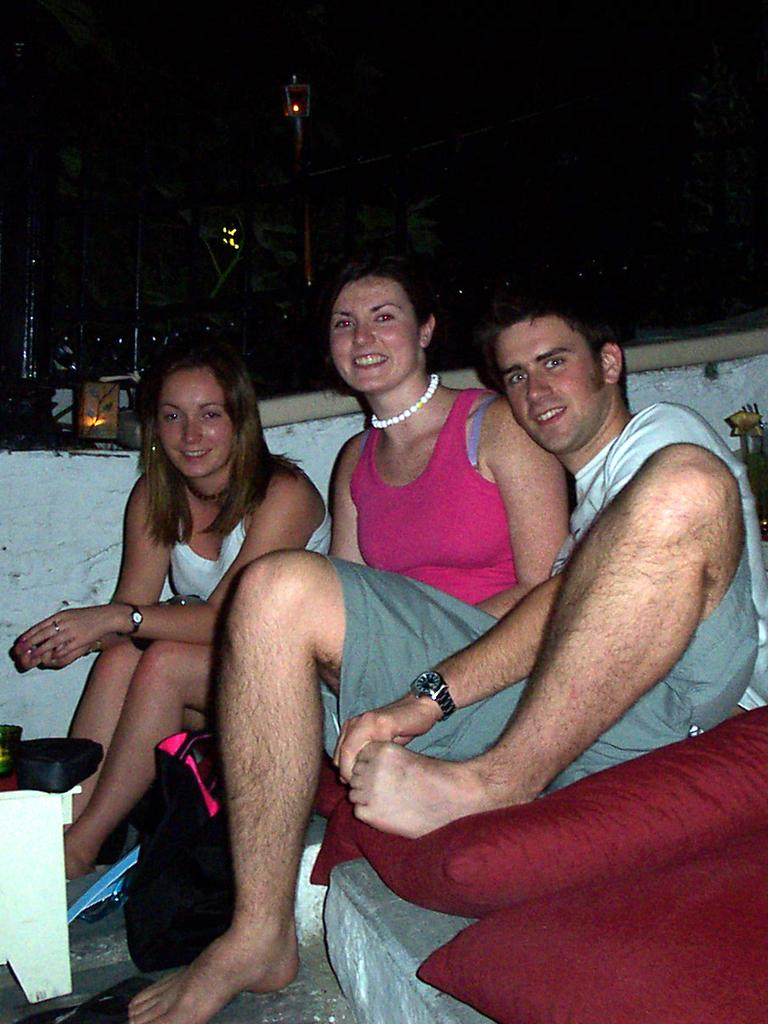What is located in the center of the image? There is a table in the center of the image. What is placed on the table? There are pillows on the table. How many people are sitting at the table? Three persons are sitting at the table. What is the facial expression of the people in the image? The persons are smiling. What can be seen in the background of the image? There are poles and lights in the background of the image. How does the wind affect the process of the visitors in the image? There is no wind, process, or visitors mentioned in the image. The image features a table with pillows and three smiling people, along with poles and lights in the background. 